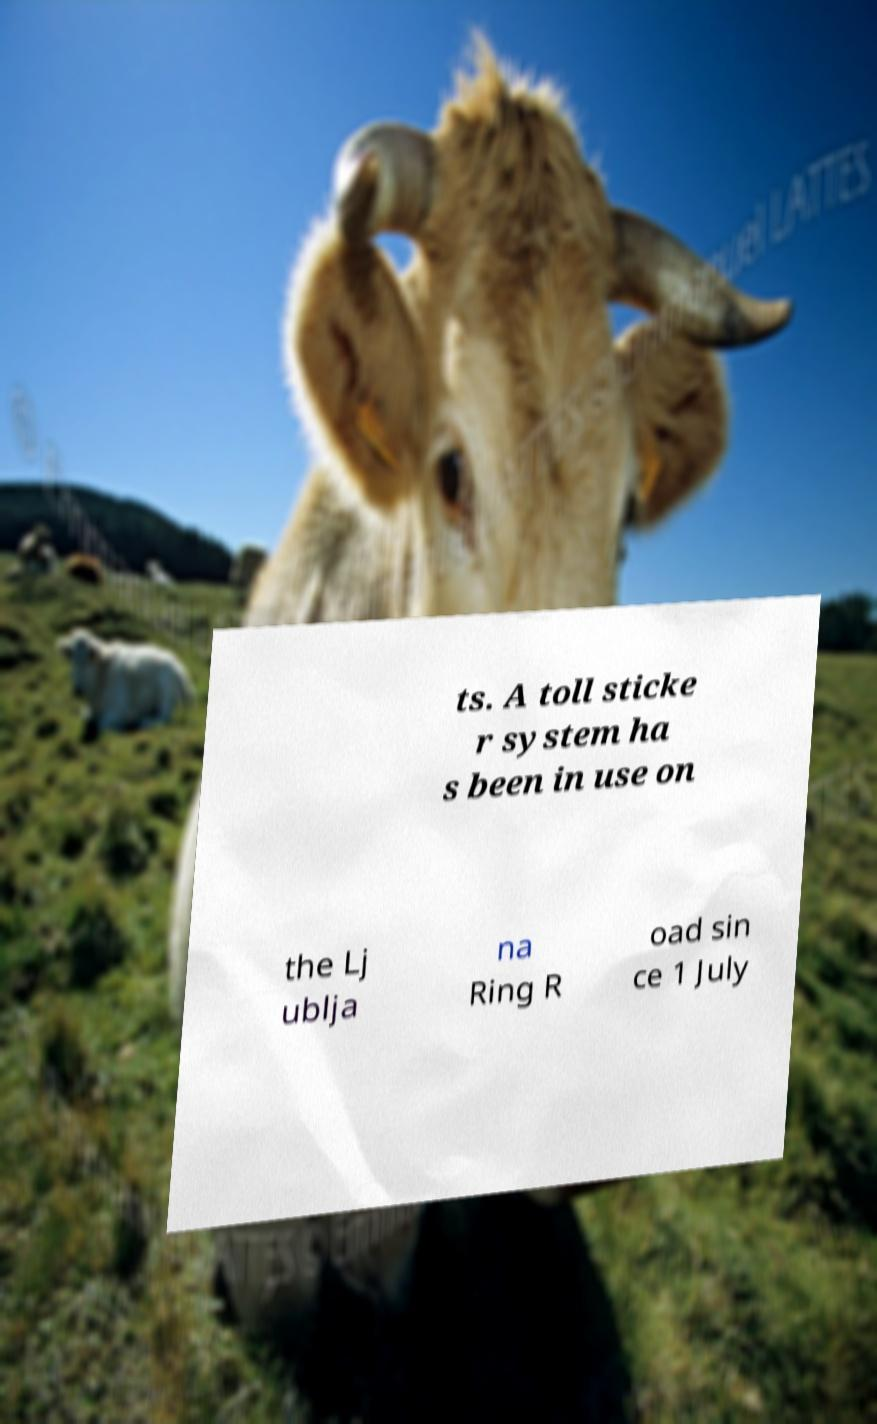For documentation purposes, I need the text within this image transcribed. Could you provide that? ts. A toll sticke r system ha s been in use on the Lj ublja na Ring R oad sin ce 1 July 